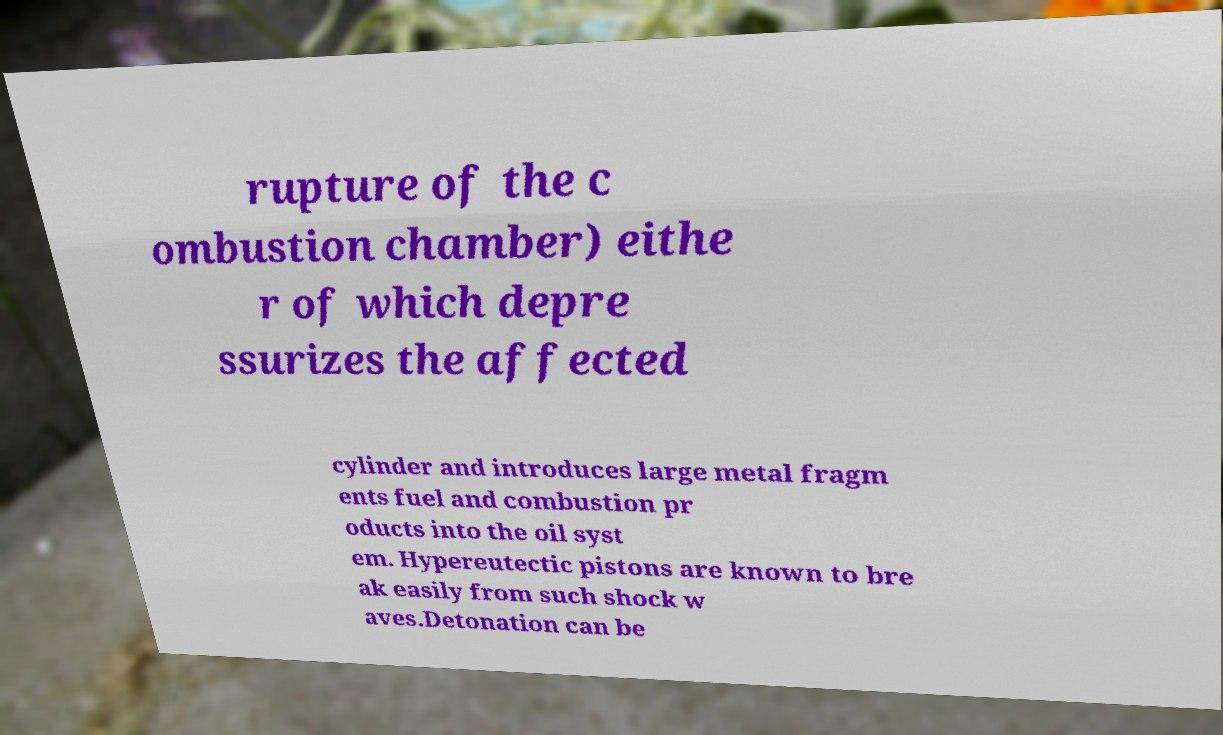Could you assist in decoding the text presented in this image and type it out clearly? rupture of the c ombustion chamber) eithe r of which depre ssurizes the affected cylinder and introduces large metal fragm ents fuel and combustion pr oducts into the oil syst em. Hypereutectic pistons are known to bre ak easily from such shock w aves.Detonation can be 